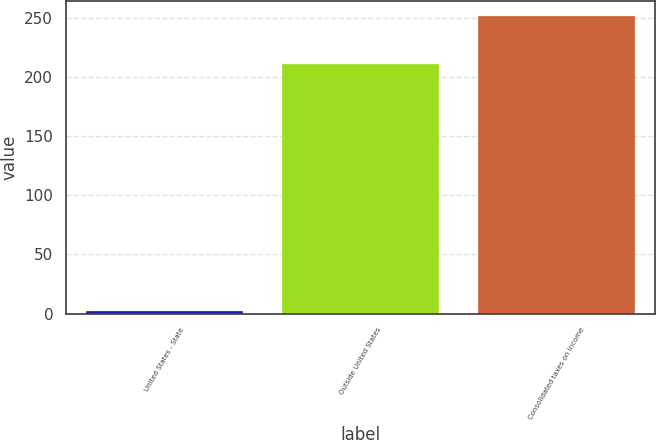Convert chart to OTSL. <chart><loc_0><loc_0><loc_500><loc_500><bar_chart><fcel>United States - State<fcel>Outside United States<fcel>Consolidated taxes on income<nl><fcel>2<fcel>211<fcel>252<nl></chart> 